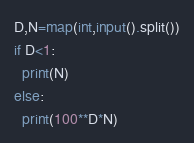<code> <loc_0><loc_0><loc_500><loc_500><_Python_>D,N=map(int,input().split())
if D<1:
  print(N)
else:
  print(100**D*N)</code> 